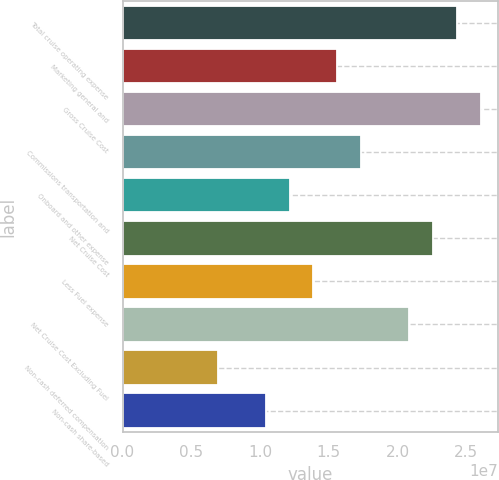Convert chart. <chart><loc_0><loc_0><loc_500><loc_500><bar_chart><fcel>Total cruise operating expense<fcel>Marketing general and<fcel>Gross Cruise Cost<fcel>Commissions transportation and<fcel>Onboard and other expense<fcel>Net Cruise Cost<fcel>Less Fuel expense<fcel>Net Cruise Cost Excluding Fuel<fcel>Non-cash deferred compensation<fcel>Non-cash share-based<nl><fcel>2.43087e+07<fcel>1.56271e+07<fcel>2.60451e+07<fcel>1.73634e+07<fcel>1.21544e+07<fcel>2.25724e+07<fcel>1.38908e+07<fcel>2.08361e+07<fcel>6.94544e+06<fcel>1.04181e+07<nl></chart> 